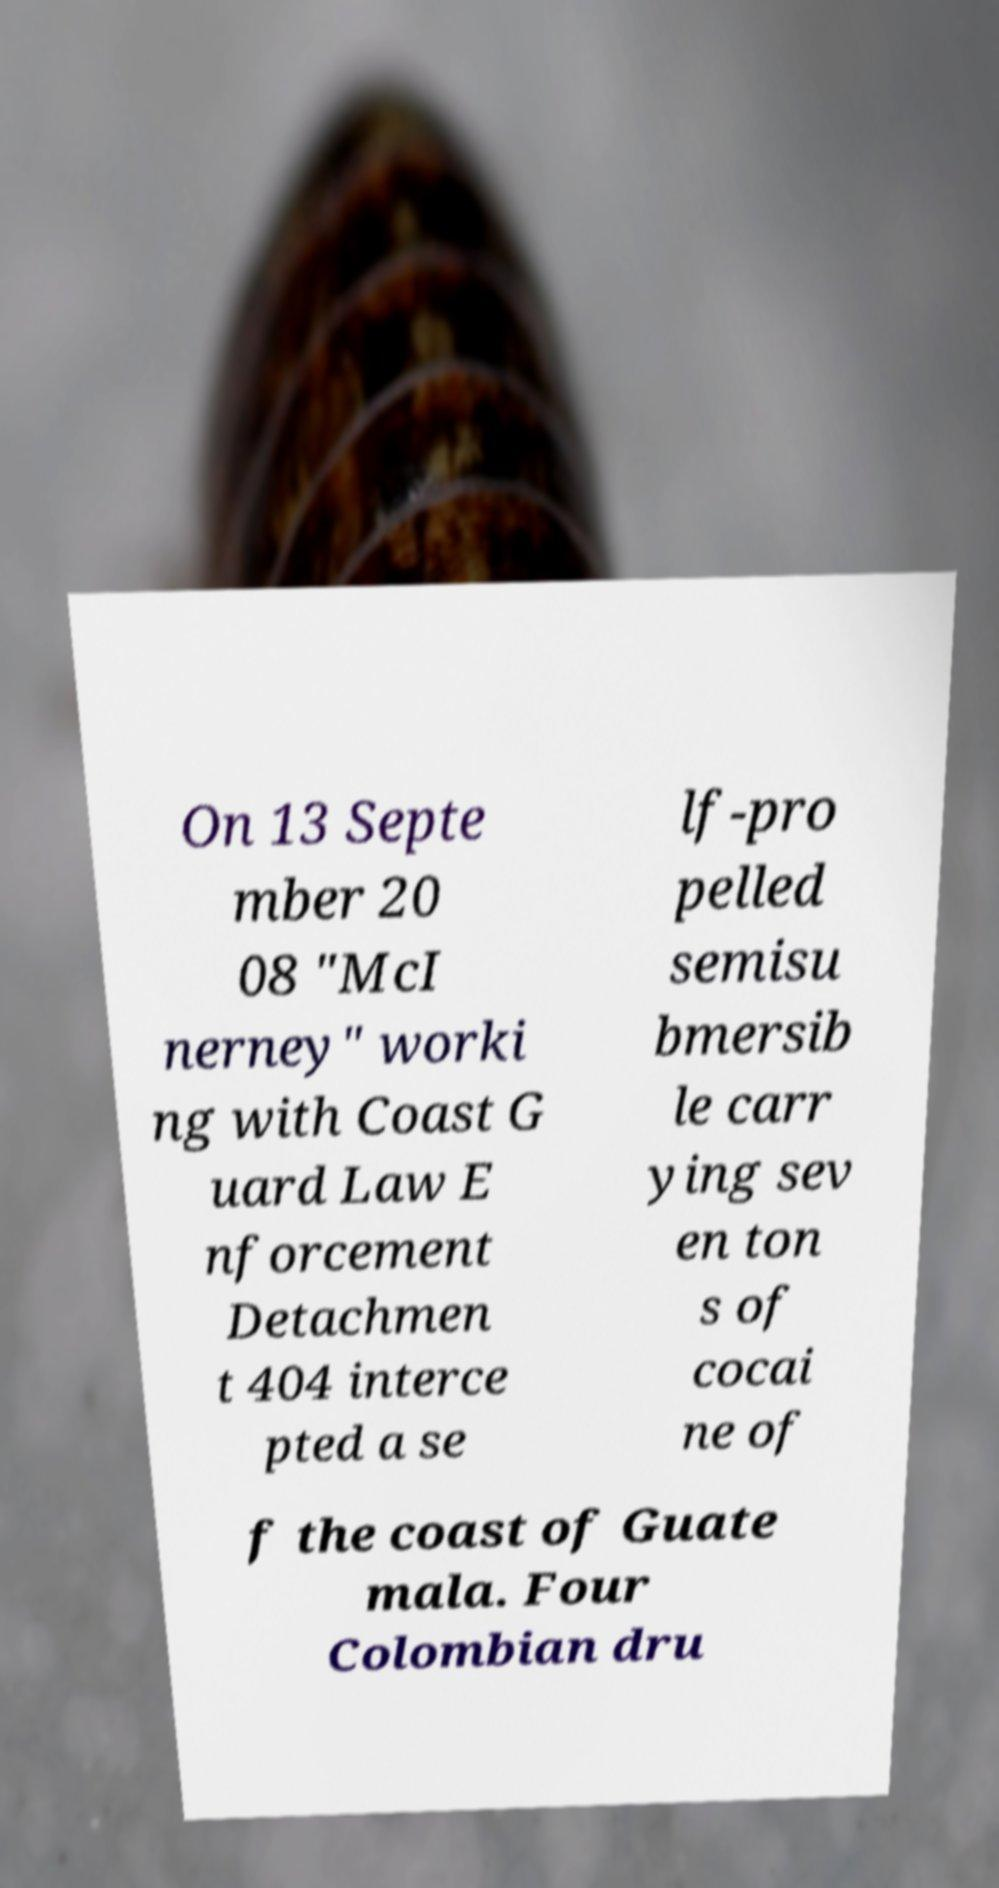What messages or text are displayed in this image? I need them in a readable, typed format. On 13 Septe mber 20 08 "McI nerney" worki ng with Coast G uard Law E nforcement Detachmen t 404 interce pted a se lf-pro pelled semisu bmersib le carr ying sev en ton s of cocai ne of f the coast of Guate mala. Four Colombian dru 